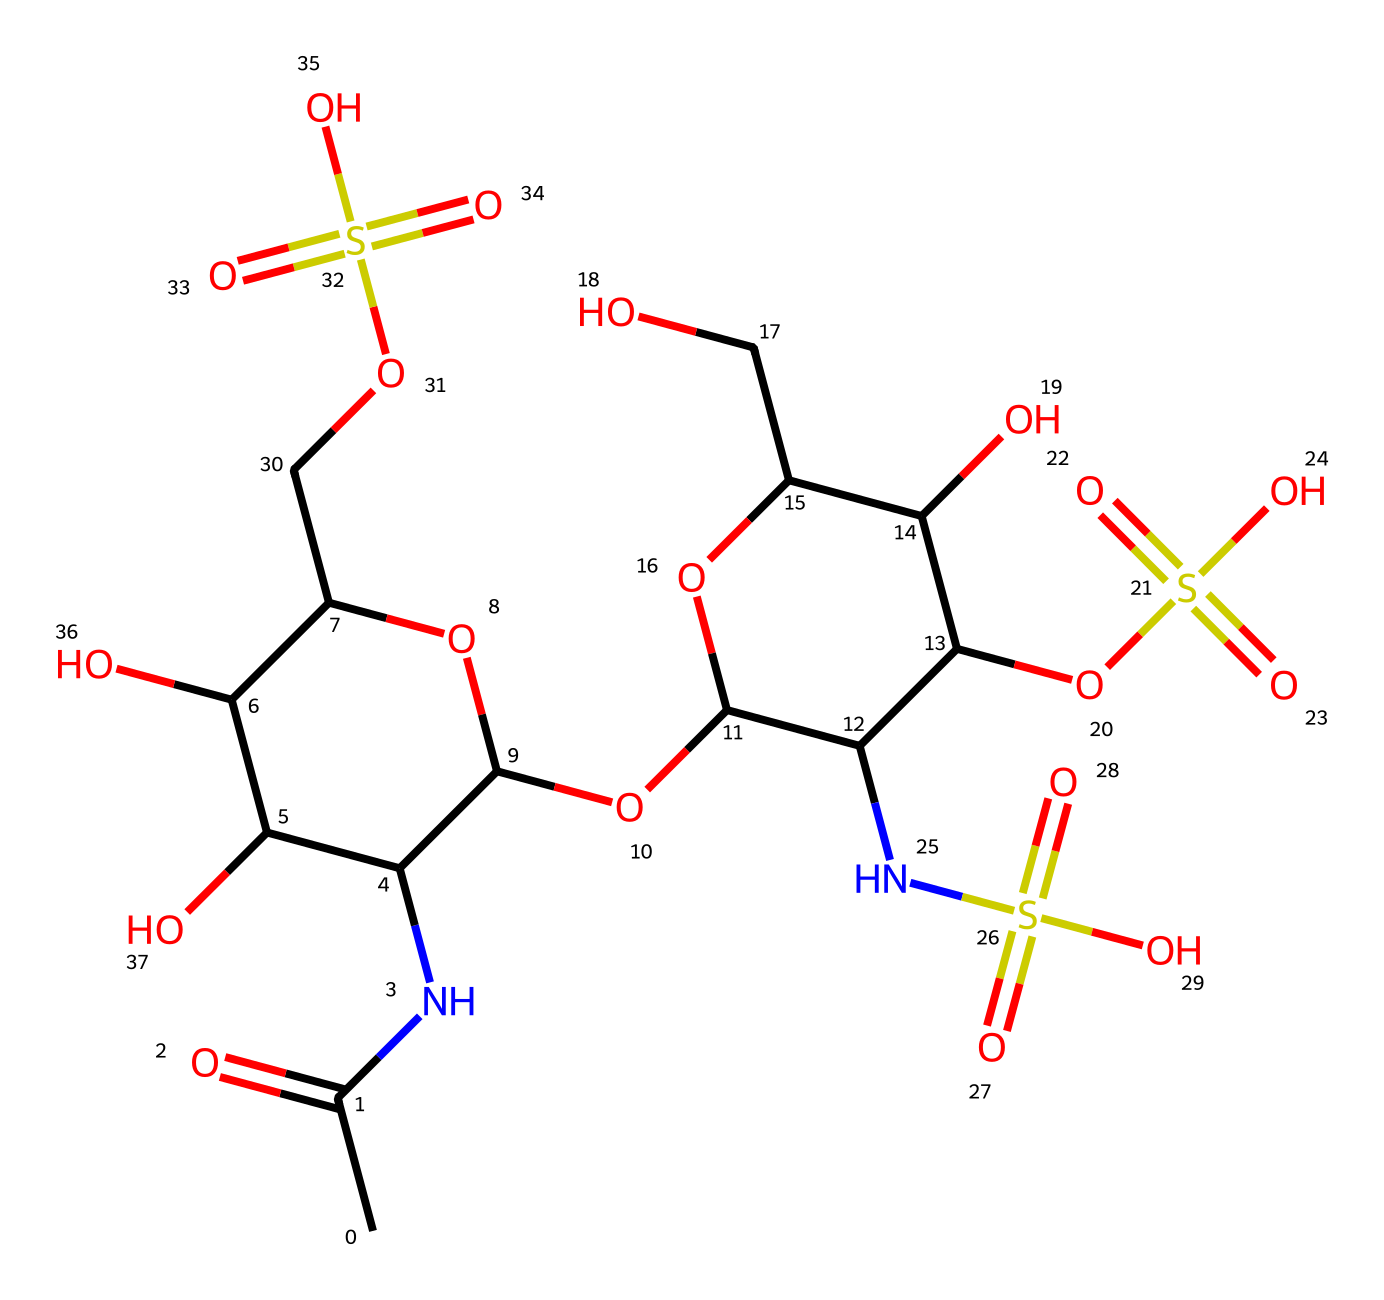What is the primary functional group present in heparin? The structure of heparin contains many functional groups, but the primary one is the sulfate group (-OS(=O)(=O)O), which is characteristic of anticoagulant properties. This group is attached to multiple carbon atoms and plays a vital role in heparin's function as an anticoagulant.
Answer: sulfate group How many sulfate groups are present in the heparin structure? By examining the SMILES structure, we can identify that there are four instances of the sulfate group (-OS(=O)(=O)O) present within the molecule. Each of these contributes to the molecule's anticoagulant activity.
Answer: four What type of carbohydrate is heparin classified as? Heparin is classified as a glycosaminoglycan, which is a unique type of carbohydrate. Glycosaminoglycans are complex polysaccharides that play critical roles in cell signaling and anti-coagulation.
Answer: glycosaminoglycan How many total oxygen atoms can be counted in this heparin structure? By analyzing the SMILES representation, we count a total of 15 oxygen atoms present throughout the structure. This is done by visually counting each "O" in the structure, including those in hydroxyl, carbonyl, and sulfate groups.
Answer: fifteen What element does the nitrogen atom represent in this heparin structure? The nitrogen atom (shown as "N" in the structure) indicates the presence of an amine group, which is a typical feature of glycosaminoglycans like heparin. This amine is crucial for the anticoagulant activity by influencing molecular interactions.
Answer: nitrogen How many rings are present in the chemical structure of heparin? Upon analyzing the heparin structure, it becomes evident that there are two ring structures incorporated into the molecule, particularly in the part that contains C(C) in the SMILES where the rings are formed by the cyclic structures.
Answer: two 